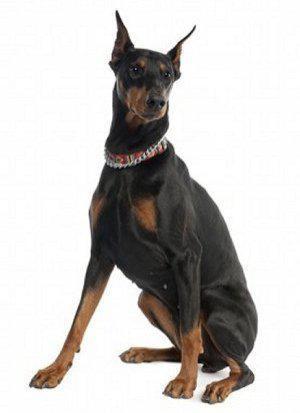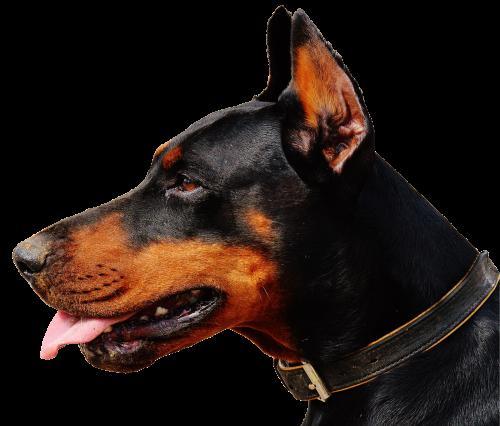The first image is the image on the left, the second image is the image on the right. Evaluate the accuracy of this statement regarding the images: "The dog in the image on the left is lying down.". Is it true? Answer yes or no. No. 